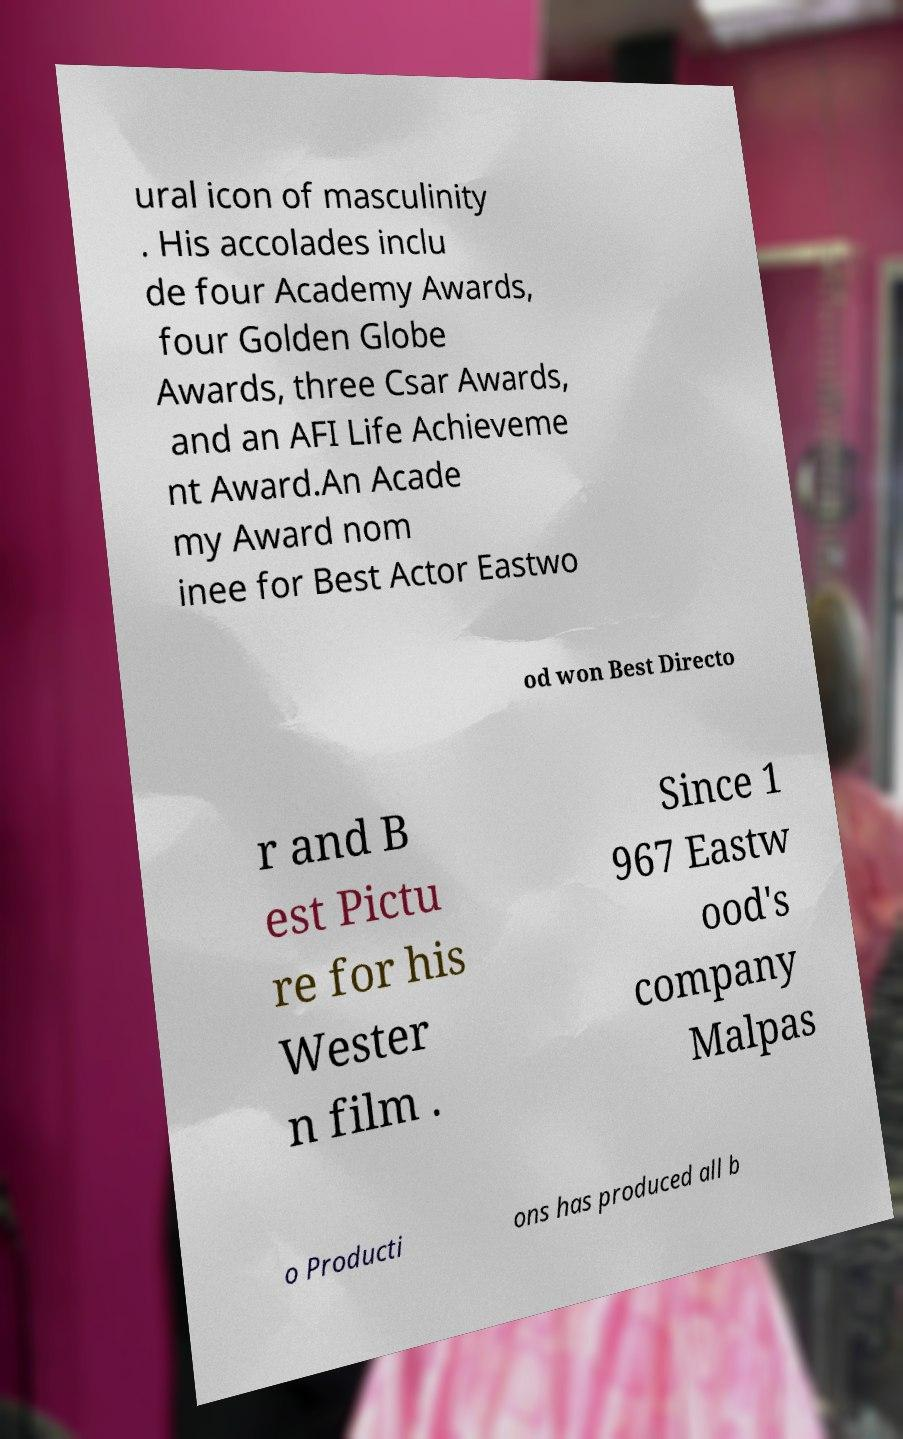I need the written content from this picture converted into text. Can you do that? ural icon of masculinity . His accolades inclu de four Academy Awards, four Golden Globe Awards, three Csar Awards, and an AFI Life Achieveme nt Award.An Acade my Award nom inee for Best Actor Eastwo od won Best Directo r and B est Pictu re for his Wester n film . Since 1 967 Eastw ood's company Malpas o Producti ons has produced all b 